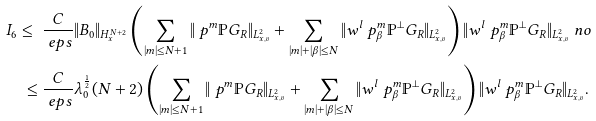Convert formula to latex. <formula><loc_0><loc_0><loc_500><loc_500>I _ { 6 } \leq \ & \frac { C } { \ e p s } \| B _ { 0 } \| _ { H ^ { N + 2 } _ { x } } \left ( \sum _ { | m | \leq N + 1 } \| \ p ^ { m } \mathbb { P } G _ { R } \| _ { L ^ { 2 } _ { x , v } } + \sum _ { | m | + | \beta | \leq N } \| w ^ { l } \ p ^ { m } _ { \beta } \mathbb { P } ^ { \perp } G _ { R } \| _ { L ^ { 2 } _ { x , v } } \right ) \| w ^ { l } \ p ^ { m } _ { \beta } \mathbb { P } ^ { \perp } G _ { R } \| _ { L ^ { 2 } _ { x , v } } \ n o \\ \leq \ & \frac { C } { \ e p s } \lambda _ { 0 } ^ { \frac { 1 } { 2 } } ( N + 2 ) \left ( \sum _ { | m | \leq N + 1 } \| \ p ^ { m } \mathbb { P } G _ { R } \| _ { L ^ { 2 } _ { x , v } } + \sum _ { | m | + | \beta | \leq N } \| w ^ { l } \ p ^ { m } _ { \beta } \mathbb { P } ^ { \perp } G _ { R } \| _ { L ^ { 2 } _ { x , v } } \right ) \| w ^ { l } \ p ^ { m } _ { \beta } \mathbb { P } ^ { \perp } G _ { R } \| _ { L ^ { 2 } _ { x , v } } .</formula> 